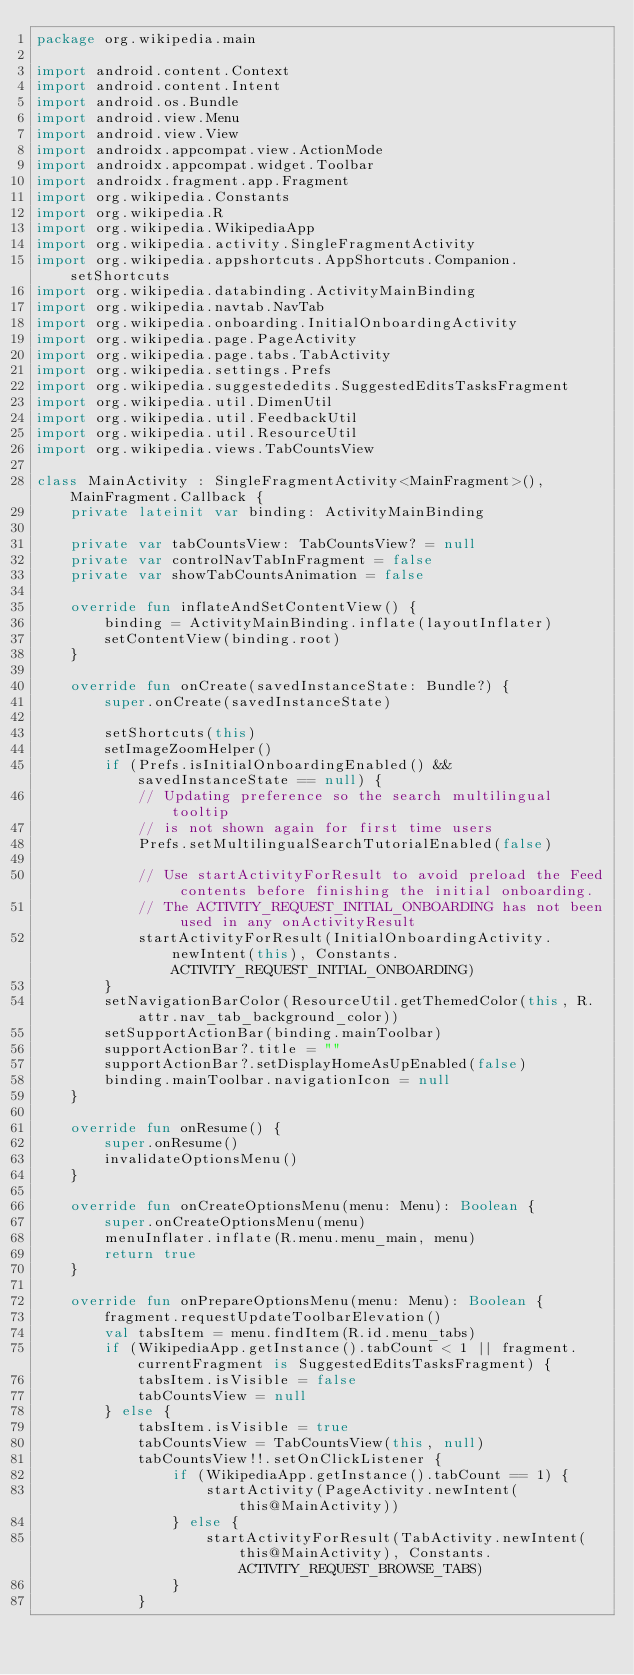<code> <loc_0><loc_0><loc_500><loc_500><_Kotlin_>package org.wikipedia.main

import android.content.Context
import android.content.Intent
import android.os.Bundle
import android.view.Menu
import android.view.View
import androidx.appcompat.view.ActionMode
import androidx.appcompat.widget.Toolbar
import androidx.fragment.app.Fragment
import org.wikipedia.Constants
import org.wikipedia.R
import org.wikipedia.WikipediaApp
import org.wikipedia.activity.SingleFragmentActivity
import org.wikipedia.appshortcuts.AppShortcuts.Companion.setShortcuts
import org.wikipedia.databinding.ActivityMainBinding
import org.wikipedia.navtab.NavTab
import org.wikipedia.onboarding.InitialOnboardingActivity
import org.wikipedia.page.PageActivity
import org.wikipedia.page.tabs.TabActivity
import org.wikipedia.settings.Prefs
import org.wikipedia.suggestededits.SuggestedEditsTasksFragment
import org.wikipedia.util.DimenUtil
import org.wikipedia.util.FeedbackUtil
import org.wikipedia.util.ResourceUtil
import org.wikipedia.views.TabCountsView

class MainActivity : SingleFragmentActivity<MainFragment>(), MainFragment.Callback {
    private lateinit var binding: ActivityMainBinding

    private var tabCountsView: TabCountsView? = null
    private var controlNavTabInFragment = false
    private var showTabCountsAnimation = false

    override fun inflateAndSetContentView() {
        binding = ActivityMainBinding.inflate(layoutInflater)
        setContentView(binding.root)
    }

    override fun onCreate(savedInstanceState: Bundle?) {
        super.onCreate(savedInstanceState)

        setShortcuts(this)
        setImageZoomHelper()
        if (Prefs.isInitialOnboardingEnabled() && savedInstanceState == null) {
            // Updating preference so the search multilingual tooltip
            // is not shown again for first time users
            Prefs.setMultilingualSearchTutorialEnabled(false)

            // Use startActivityForResult to avoid preload the Feed contents before finishing the initial onboarding.
            // The ACTIVITY_REQUEST_INITIAL_ONBOARDING has not been used in any onActivityResult
            startActivityForResult(InitialOnboardingActivity.newIntent(this), Constants.ACTIVITY_REQUEST_INITIAL_ONBOARDING)
        }
        setNavigationBarColor(ResourceUtil.getThemedColor(this, R.attr.nav_tab_background_color))
        setSupportActionBar(binding.mainToolbar)
        supportActionBar?.title = ""
        supportActionBar?.setDisplayHomeAsUpEnabled(false)
        binding.mainToolbar.navigationIcon = null
    }

    override fun onResume() {
        super.onResume()
        invalidateOptionsMenu()
    }

    override fun onCreateOptionsMenu(menu: Menu): Boolean {
        super.onCreateOptionsMenu(menu)
        menuInflater.inflate(R.menu.menu_main, menu)
        return true
    }

    override fun onPrepareOptionsMenu(menu: Menu): Boolean {
        fragment.requestUpdateToolbarElevation()
        val tabsItem = menu.findItem(R.id.menu_tabs)
        if (WikipediaApp.getInstance().tabCount < 1 || fragment.currentFragment is SuggestedEditsTasksFragment) {
            tabsItem.isVisible = false
            tabCountsView = null
        } else {
            tabsItem.isVisible = true
            tabCountsView = TabCountsView(this, null)
            tabCountsView!!.setOnClickListener {
                if (WikipediaApp.getInstance().tabCount == 1) {
                    startActivity(PageActivity.newIntent(this@MainActivity))
                } else {
                    startActivityForResult(TabActivity.newIntent(this@MainActivity), Constants.ACTIVITY_REQUEST_BROWSE_TABS)
                }
            }</code> 